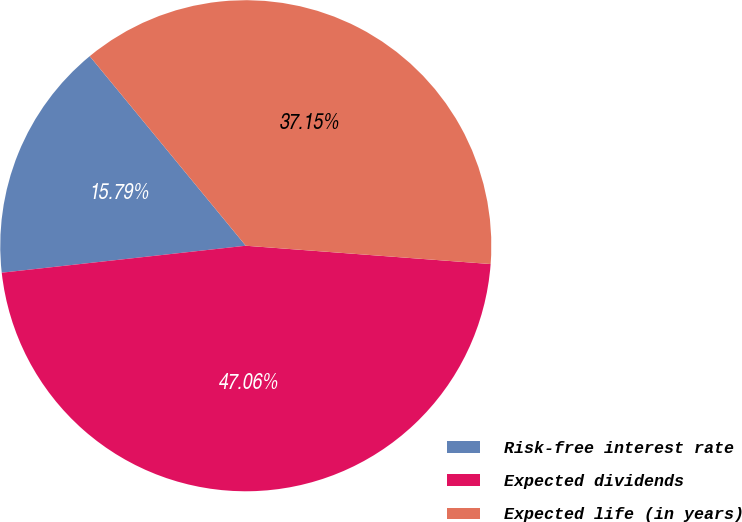Convert chart. <chart><loc_0><loc_0><loc_500><loc_500><pie_chart><fcel>Risk-free interest rate<fcel>Expected dividends<fcel>Expected life (in years)<nl><fcel>15.79%<fcel>47.06%<fcel>37.15%<nl></chart> 